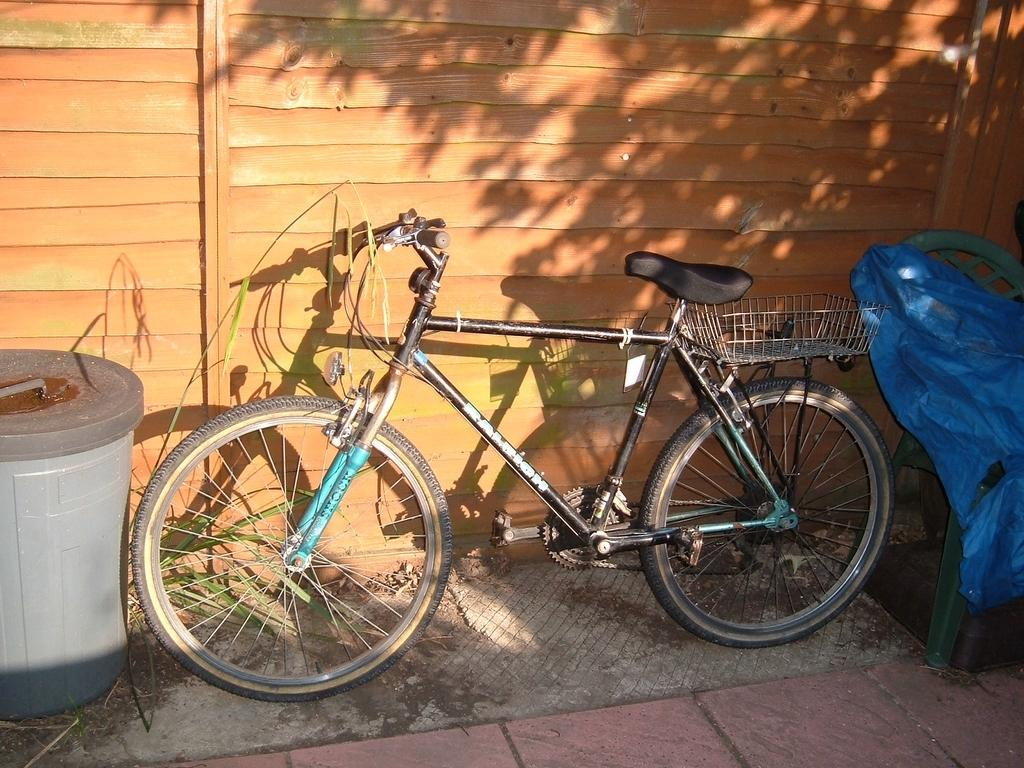What is the main object in the image? There is a bicycle in the image. What other object can be seen in the image? There is an object in the image. What type of furniture is present in the image? There is a chair in the image. How is the chair covered in the image? There is a cover on the chair in the image. Where is the chair and the cover located in the image? The chair and the cover are near a wall in the image. How do the horses feel about the shame they are experiencing in the image? There are no horses present in the image, so it is not possible to determine how they might feel about any shame. 